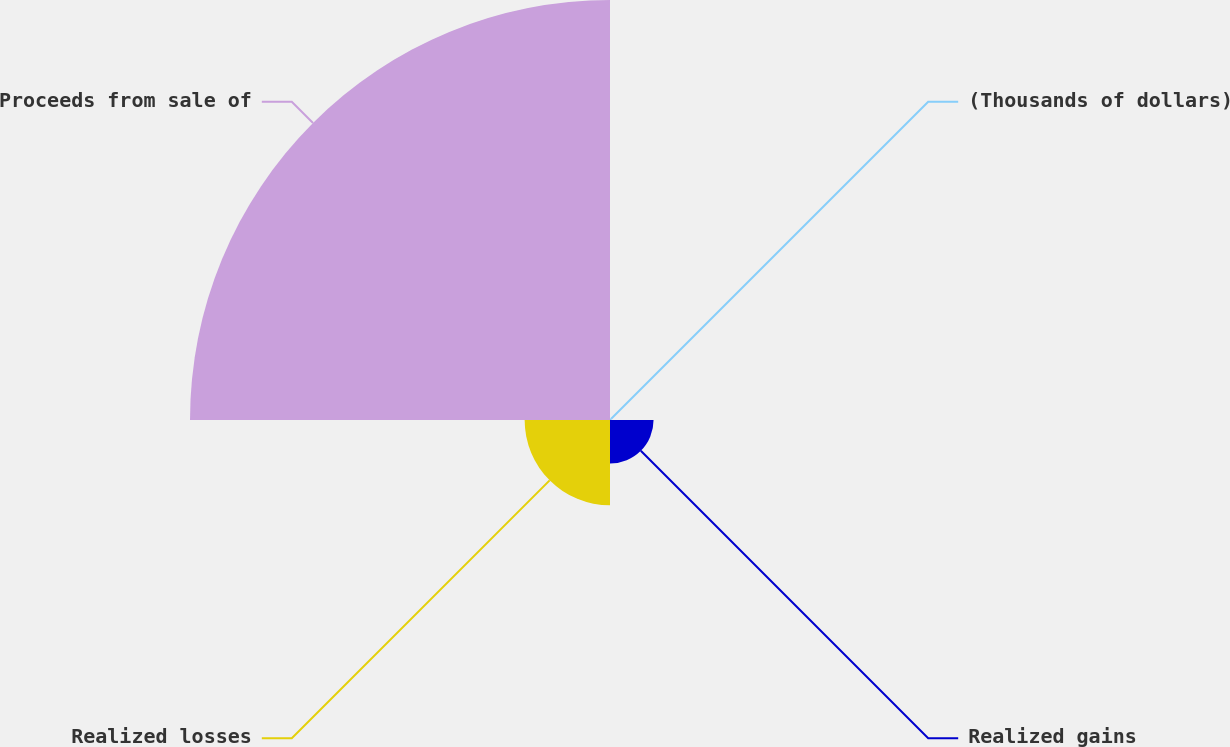Convert chart. <chart><loc_0><loc_0><loc_500><loc_500><pie_chart><fcel>(Thousands of dollars)<fcel>Realized gains<fcel>Realized losses<fcel>Proceeds from sale of<nl><fcel>0.31%<fcel>7.91%<fcel>15.5%<fcel>76.27%<nl></chart> 